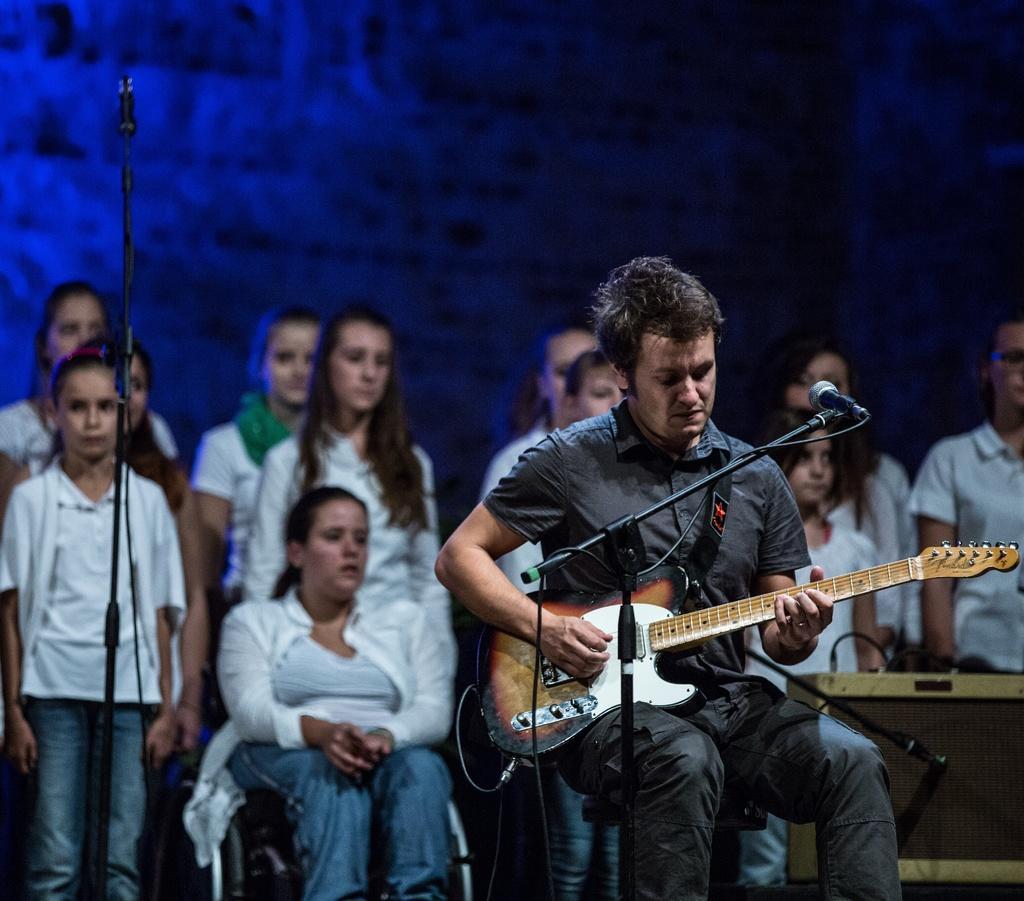In one or two sentences, can you explain what this image depicts? In this image i can see a person sitting on a chair and holding a guitar. i can see a microphone in front of him. In the background i can see few people standing and the wall. 